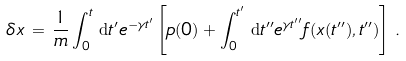<formula> <loc_0><loc_0><loc_500><loc_500>\delta x \, = \, \frac { 1 } { m } \int _ { 0 } ^ { t } \, { \mathrm d } t ^ { \prime } e ^ { - \gamma t ^ { \prime } } \left [ p ( 0 ) + \int _ { 0 } ^ { t ^ { \prime } } \, { \mathrm d } t ^ { \prime \prime } e ^ { \gamma t ^ { \prime \prime } } f ( x ( t ^ { \prime \prime } ) , t ^ { \prime \prime } ) \right ] \, .</formula> 